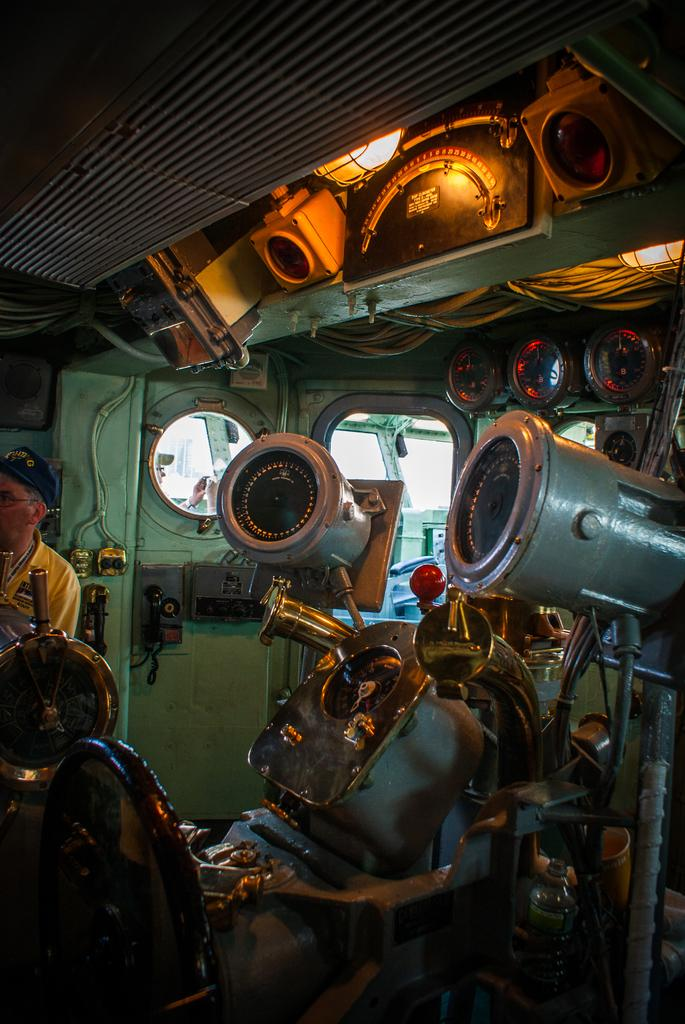What type of location is depicted in the image? The image is an inside view of a train. What are the people in the image doing? People are staring in the image. Can you describe the position of the person on the left side of the image? There is a person standing on the left side of the image. What color is the t-shirt worn by the person on the left side of the image? The person is wearing a yellow t-shirt. What type of vegetable is being used as a toy by the person on the left side of the image? There is no vegetable or toy present in the image; the person is wearing a yellow t-shirt. 